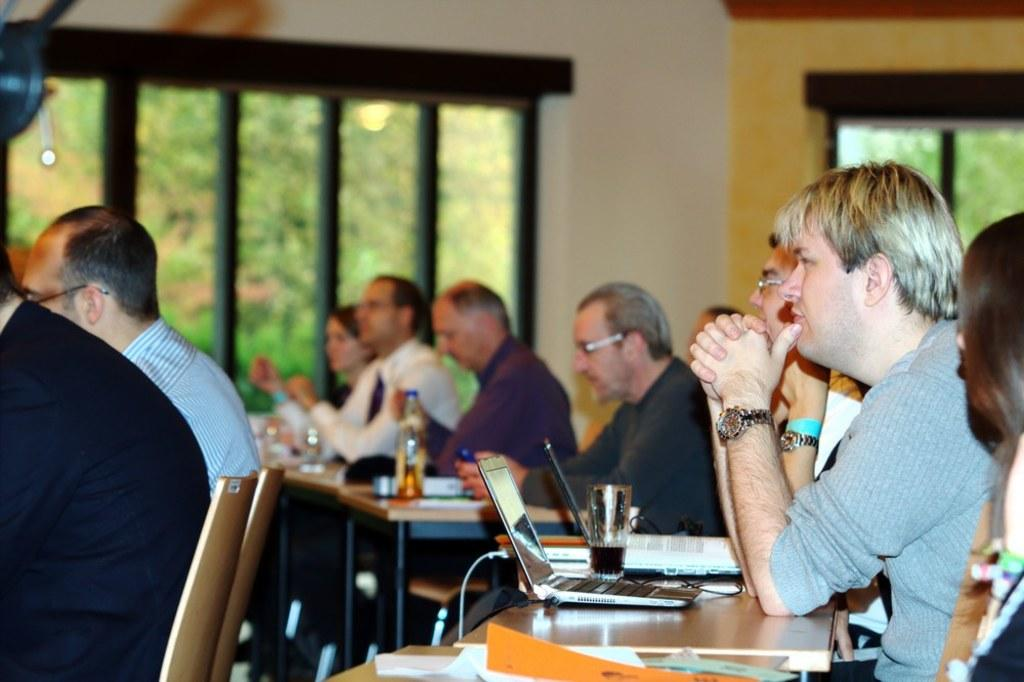Who or what is present in the image? There are people in the image. What are the people doing in the image? The people are sitting on chairs. What type of van can be seen in the image? There is no van present in the image; it only features people sitting on chairs. 